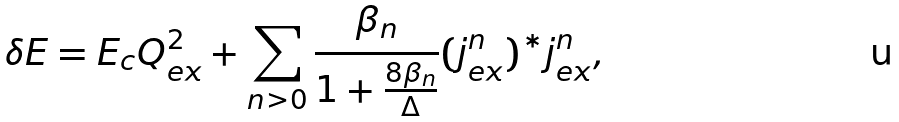<formula> <loc_0><loc_0><loc_500><loc_500>\delta E = E _ { c } Q _ { e x } ^ { 2 } + \sum _ { n > 0 } \frac { \beta _ { n } } { 1 + \frac { 8 \beta _ { n } } { \Delta } } ( j _ { e x } ^ { n } ) ^ { * } j _ { e x } ^ { n } ,</formula> 